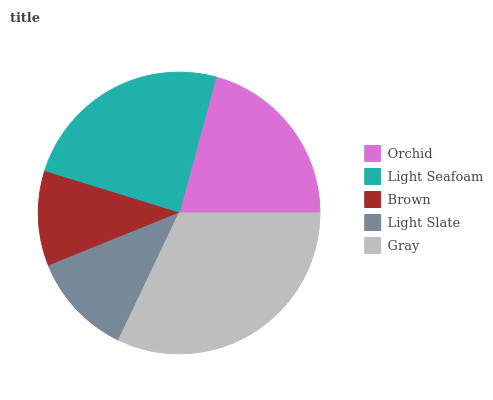Is Brown the minimum?
Answer yes or no. Yes. Is Gray the maximum?
Answer yes or no. Yes. Is Light Seafoam the minimum?
Answer yes or no. No. Is Light Seafoam the maximum?
Answer yes or no. No. Is Light Seafoam greater than Orchid?
Answer yes or no. Yes. Is Orchid less than Light Seafoam?
Answer yes or no. Yes. Is Orchid greater than Light Seafoam?
Answer yes or no. No. Is Light Seafoam less than Orchid?
Answer yes or no. No. Is Orchid the high median?
Answer yes or no. Yes. Is Orchid the low median?
Answer yes or no. Yes. Is Brown the high median?
Answer yes or no. No. Is Light Slate the low median?
Answer yes or no. No. 